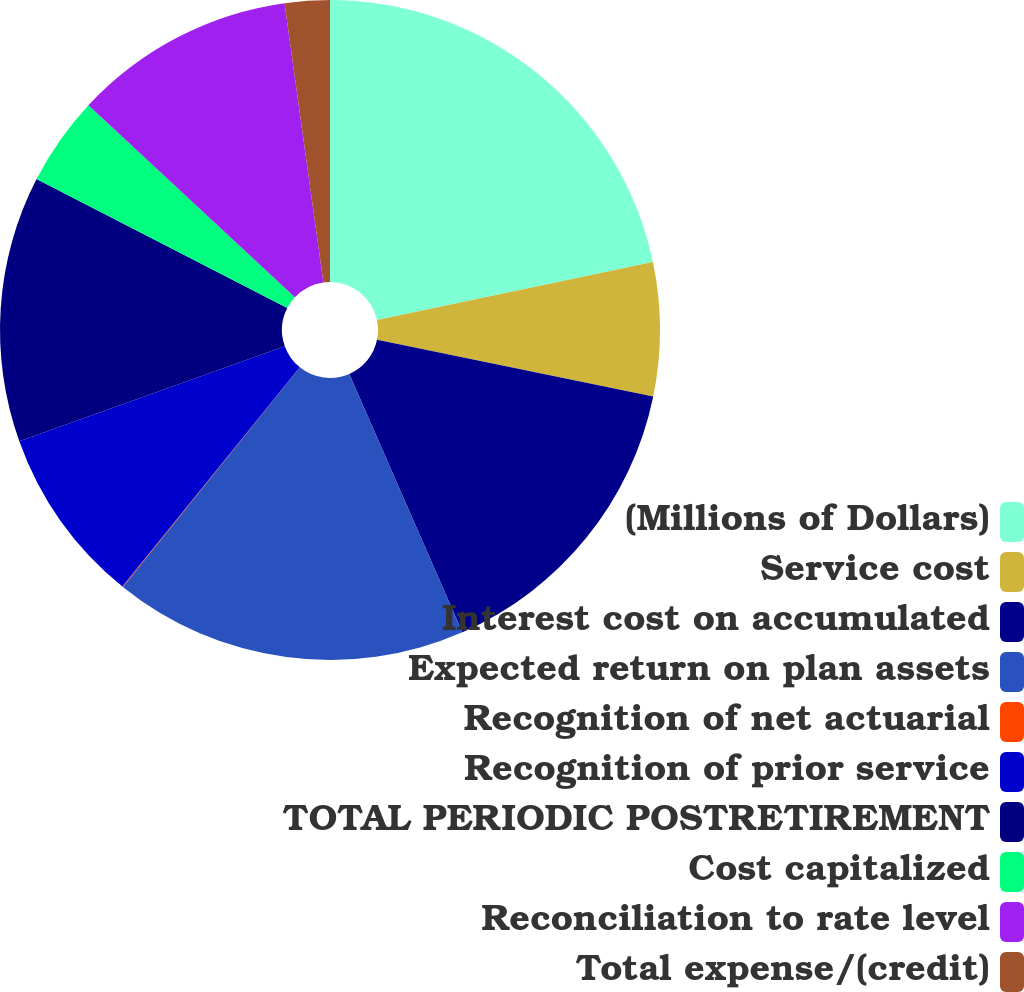Convert chart. <chart><loc_0><loc_0><loc_500><loc_500><pie_chart><fcel>(Millions of Dollars)<fcel>Service cost<fcel>Interest cost on accumulated<fcel>Expected return on plan assets<fcel>Recognition of net actuarial<fcel>Recognition of prior service<fcel>TOTAL PERIODIC POSTRETIREMENT<fcel>Cost capitalized<fcel>Reconciliation to rate level<fcel>Total expense/(credit)<nl><fcel>21.7%<fcel>6.53%<fcel>15.2%<fcel>17.37%<fcel>0.03%<fcel>8.7%<fcel>13.03%<fcel>4.37%<fcel>10.87%<fcel>2.2%<nl></chart> 